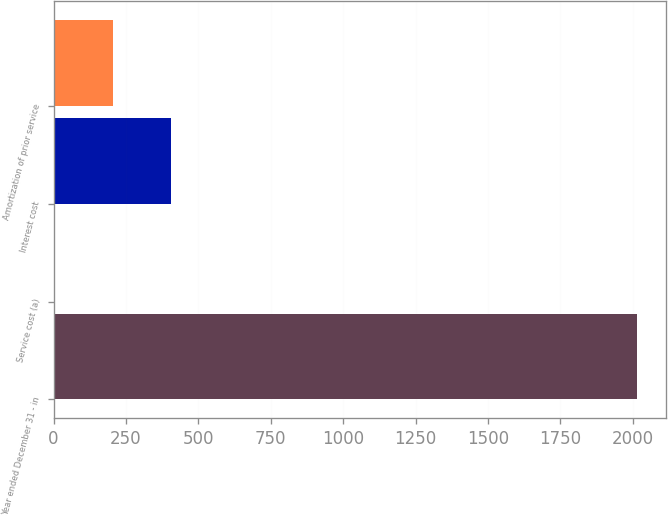Convert chart. <chart><loc_0><loc_0><loc_500><loc_500><bar_chart><fcel>Year ended December 31 - in<fcel>Service cost (a)<fcel>Interest cost<fcel>Amortization of prior service<nl><fcel>2015<fcel>5<fcel>407<fcel>206<nl></chart> 